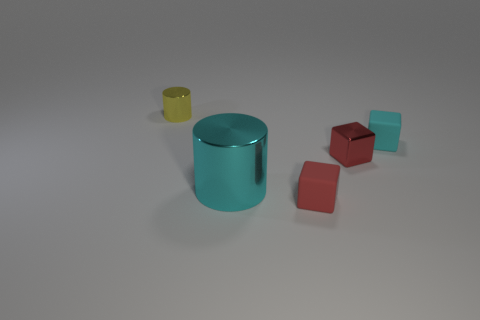Subtract all tiny matte blocks. How many blocks are left? 1 Subtract all cyan cylinders. How many red cubes are left? 2 Subtract 1 blocks. How many blocks are left? 2 Add 4 yellow metallic cylinders. How many objects exist? 9 Subtract all cubes. How many objects are left? 2 Subtract all purple blocks. Subtract all cyan cylinders. How many blocks are left? 3 Subtract all tiny red objects. Subtract all cyan cylinders. How many objects are left? 2 Add 1 red shiny blocks. How many red shiny blocks are left? 2 Add 2 red metallic blocks. How many red metallic blocks exist? 3 Subtract 0 gray cylinders. How many objects are left? 5 